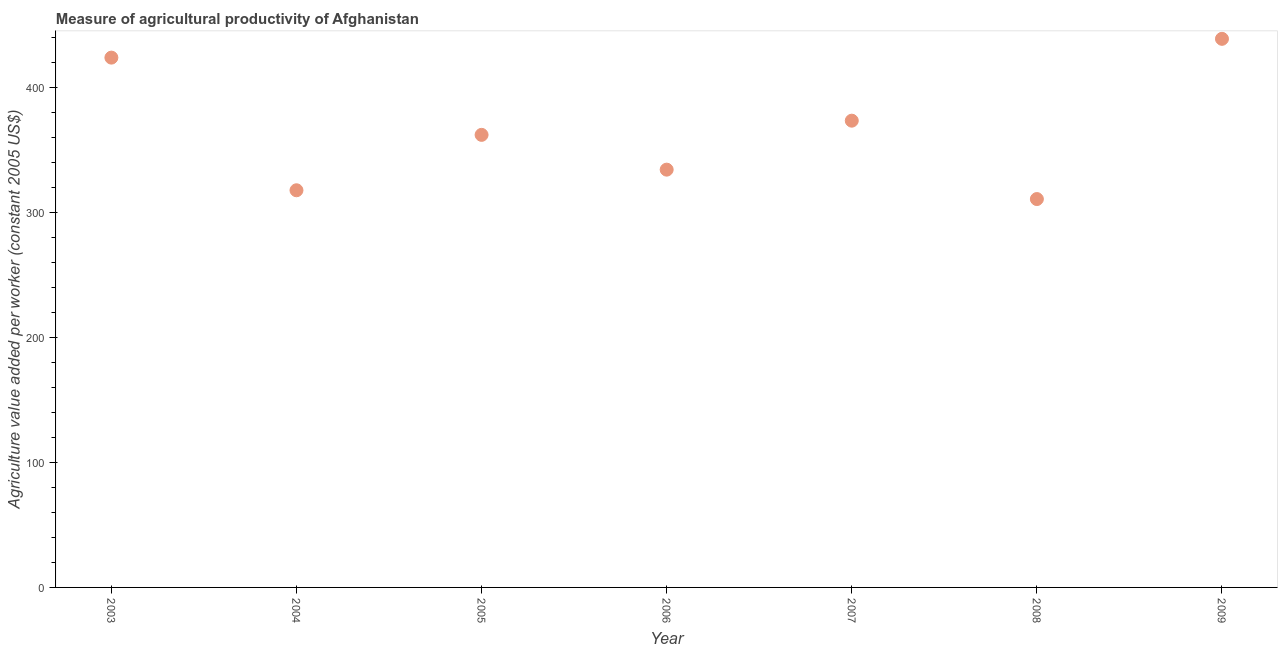What is the agriculture value added per worker in 2007?
Offer a terse response. 373.34. Across all years, what is the maximum agriculture value added per worker?
Give a very brief answer. 438.8. Across all years, what is the minimum agriculture value added per worker?
Give a very brief answer. 310.65. In which year was the agriculture value added per worker minimum?
Make the answer very short. 2008. What is the sum of the agriculture value added per worker?
Provide a succinct answer. 2560.42. What is the difference between the agriculture value added per worker in 2003 and 2008?
Ensure brevity in your answer.  113.13. What is the average agriculture value added per worker per year?
Ensure brevity in your answer.  365.77. What is the median agriculture value added per worker?
Ensure brevity in your answer.  362. In how many years, is the agriculture value added per worker greater than 180 US$?
Make the answer very short. 7. What is the ratio of the agriculture value added per worker in 2004 to that in 2006?
Your answer should be very brief. 0.95. Is the difference between the agriculture value added per worker in 2003 and 2008 greater than the difference between any two years?
Ensure brevity in your answer.  No. What is the difference between the highest and the second highest agriculture value added per worker?
Offer a terse response. 15.03. Is the sum of the agriculture value added per worker in 2004 and 2007 greater than the maximum agriculture value added per worker across all years?
Provide a succinct answer. Yes. What is the difference between the highest and the lowest agriculture value added per worker?
Provide a short and direct response. 128.16. How many dotlines are there?
Provide a short and direct response. 1. What is the difference between two consecutive major ticks on the Y-axis?
Keep it short and to the point. 100. What is the title of the graph?
Ensure brevity in your answer.  Measure of agricultural productivity of Afghanistan. What is the label or title of the Y-axis?
Make the answer very short. Agriculture value added per worker (constant 2005 US$). What is the Agriculture value added per worker (constant 2005 US$) in 2003?
Offer a very short reply. 423.78. What is the Agriculture value added per worker (constant 2005 US$) in 2004?
Ensure brevity in your answer.  317.68. What is the Agriculture value added per worker (constant 2005 US$) in 2005?
Offer a terse response. 362. What is the Agriculture value added per worker (constant 2005 US$) in 2006?
Your answer should be compact. 334.17. What is the Agriculture value added per worker (constant 2005 US$) in 2007?
Keep it short and to the point. 373.34. What is the Agriculture value added per worker (constant 2005 US$) in 2008?
Give a very brief answer. 310.65. What is the Agriculture value added per worker (constant 2005 US$) in 2009?
Give a very brief answer. 438.8. What is the difference between the Agriculture value added per worker (constant 2005 US$) in 2003 and 2004?
Make the answer very short. 106.1. What is the difference between the Agriculture value added per worker (constant 2005 US$) in 2003 and 2005?
Provide a succinct answer. 61.78. What is the difference between the Agriculture value added per worker (constant 2005 US$) in 2003 and 2006?
Give a very brief answer. 89.6. What is the difference between the Agriculture value added per worker (constant 2005 US$) in 2003 and 2007?
Provide a succinct answer. 50.43. What is the difference between the Agriculture value added per worker (constant 2005 US$) in 2003 and 2008?
Offer a very short reply. 113.13. What is the difference between the Agriculture value added per worker (constant 2005 US$) in 2003 and 2009?
Your response must be concise. -15.03. What is the difference between the Agriculture value added per worker (constant 2005 US$) in 2004 and 2005?
Provide a succinct answer. -44.32. What is the difference between the Agriculture value added per worker (constant 2005 US$) in 2004 and 2006?
Offer a very short reply. -16.5. What is the difference between the Agriculture value added per worker (constant 2005 US$) in 2004 and 2007?
Provide a short and direct response. -55.67. What is the difference between the Agriculture value added per worker (constant 2005 US$) in 2004 and 2008?
Your response must be concise. 7.03. What is the difference between the Agriculture value added per worker (constant 2005 US$) in 2004 and 2009?
Give a very brief answer. -121.13. What is the difference between the Agriculture value added per worker (constant 2005 US$) in 2005 and 2006?
Your response must be concise. 27.82. What is the difference between the Agriculture value added per worker (constant 2005 US$) in 2005 and 2007?
Keep it short and to the point. -11.35. What is the difference between the Agriculture value added per worker (constant 2005 US$) in 2005 and 2008?
Your answer should be very brief. 51.35. What is the difference between the Agriculture value added per worker (constant 2005 US$) in 2005 and 2009?
Provide a succinct answer. -76.81. What is the difference between the Agriculture value added per worker (constant 2005 US$) in 2006 and 2007?
Keep it short and to the point. -39.17. What is the difference between the Agriculture value added per worker (constant 2005 US$) in 2006 and 2008?
Provide a short and direct response. 23.53. What is the difference between the Agriculture value added per worker (constant 2005 US$) in 2006 and 2009?
Provide a short and direct response. -104.63. What is the difference between the Agriculture value added per worker (constant 2005 US$) in 2007 and 2008?
Your answer should be very brief. 62.7. What is the difference between the Agriculture value added per worker (constant 2005 US$) in 2007 and 2009?
Offer a terse response. -65.46. What is the difference between the Agriculture value added per worker (constant 2005 US$) in 2008 and 2009?
Ensure brevity in your answer.  -128.16. What is the ratio of the Agriculture value added per worker (constant 2005 US$) in 2003 to that in 2004?
Provide a succinct answer. 1.33. What is the ratio of the Agriculture value added per worker (constant 2005 US$) in 2003 to that in 2005?
Your response must be concise. 1.17. What is the ratio of the Agriculture value added per worker (constant 2005 US$) in 2003 to that in 2006?
Provide a succinct answer. 1.27. What is the ratio of the Agriculture value added per worker (constant 2005 US$) in 2003 to that in 2007?
Offer a very short reply. 1.14. What is the ratio of the Agriculture value added per worker (constant 2005 US$) in 2003 to that in 2008?
Provide a short and direct response. 1.36. What is the ratio of the Agriculture value added per worker (constant 2005 US$) in 2004 to that in 2005?
Make the answer very short. 0.88. What is the ratio of the Agriculture value added per worker (constant 2005 US$) in 2004 to that in 2006?
Give a very brief answer. 0.95. What is the ratio of the Agriculture value added per worker (constant 2005 US$) in 2004 to that in 2007?
Keep it short and to the point. 0.85. What is the ratio of the Agriculture value added per worker (constant 2005 US$) in 2004 to that in 2008?
Make the answer very short. 1.02. What is the ratio of the Agriculture value added per worker (constant 2005 US$) in 2004 to that in 2009?
Keep it short and to the point. 0.72. What is the ratio of the Agriculture value added per worker (constant 2005 US$) in 2005 to that in 2006?
Make the answer very short. 1.08. What is the ratio of the Agriculture value added per worker (constant 2005 US$) in 2005 to that in 2008?
Make the answer very short. 1.17. What is the ratio of the Agriculture value added per worker (constant 2005 US$) in 2005 to that in 2009?
Provide a short and direct response. 0.82. What is the ratio of the Agriculture value added per worker (constant 2005 US$) in 2006 to that in 2007?
Offer a terse response. 0.9. What is the ratio of the Agriculture value added per worker (constant 2005 US$) in 2006 to that in 2008?
Keep it short and to the point. 1.08. What is the ratio of the Agriculture value added per worker (constant 2005 US$) in 2006 to that in 2009?
Your response must be concise. 0.76. What is the ratio of the Agriculture value added per worker (constant 2005 US$) in 2007 to that in 2008?
Provide a succinct answer. 1.2. What is the ratio of the Agriculture value added per worker (constant 2005 US$) in 2007 to that in 2009?
Make the answer very short. 0.85. What is the ratio of the Agriculture value added per worker (constant 2005 US$) in 2008 to that in 2009?
Provide a short and direct response. 0.71. 